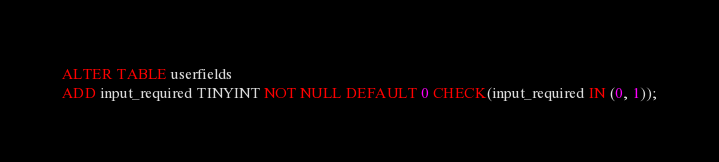Convert code to text. <code><loc_0><loc_0><loc_500><loc_500><_SQL_>ALTER TABLE userfields
ADD input_required TINYINT NOT NULL DEFAULT 0 CHECK(input_required IN (0, 1));
</code> 